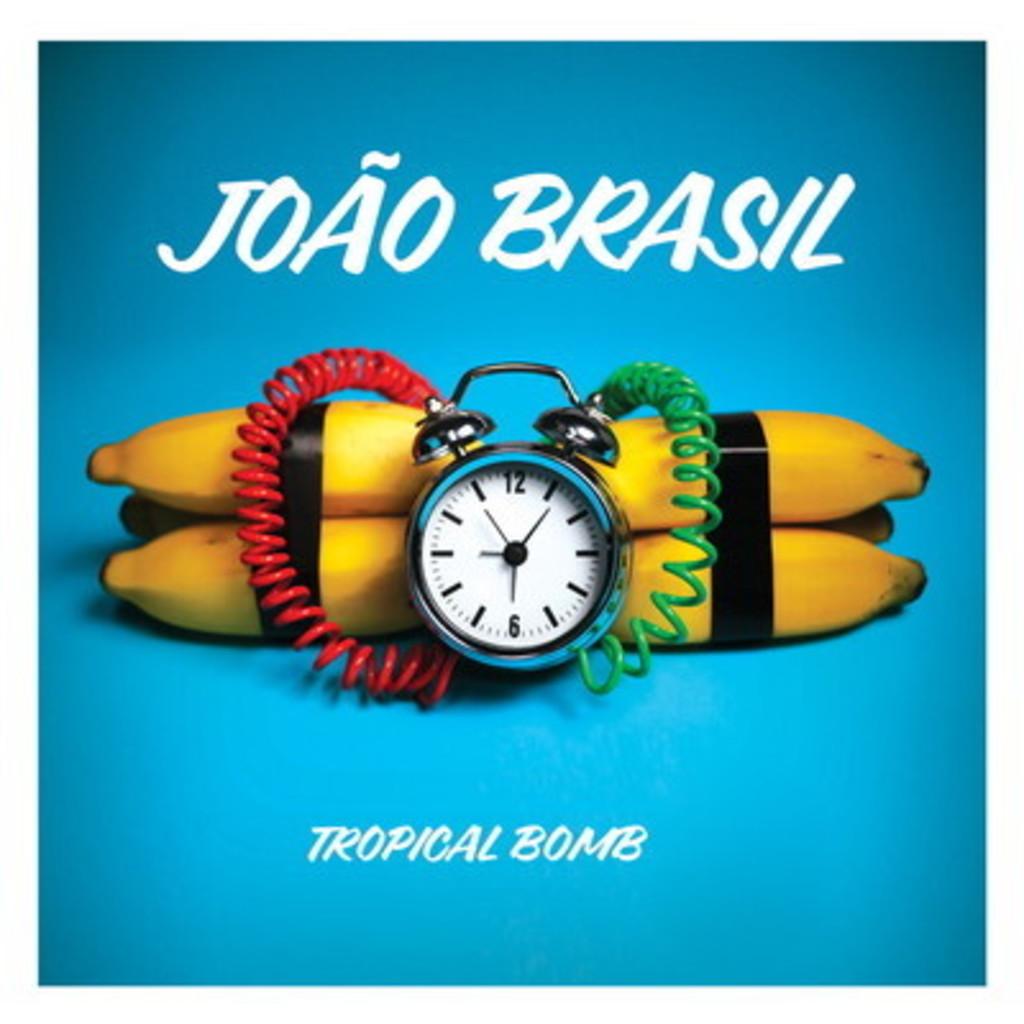What are the two words at the bottom under the bananas?
Make the answer very short. Tropical bomb. What kind of bomb?
Offer a very short reply. Tropical. 